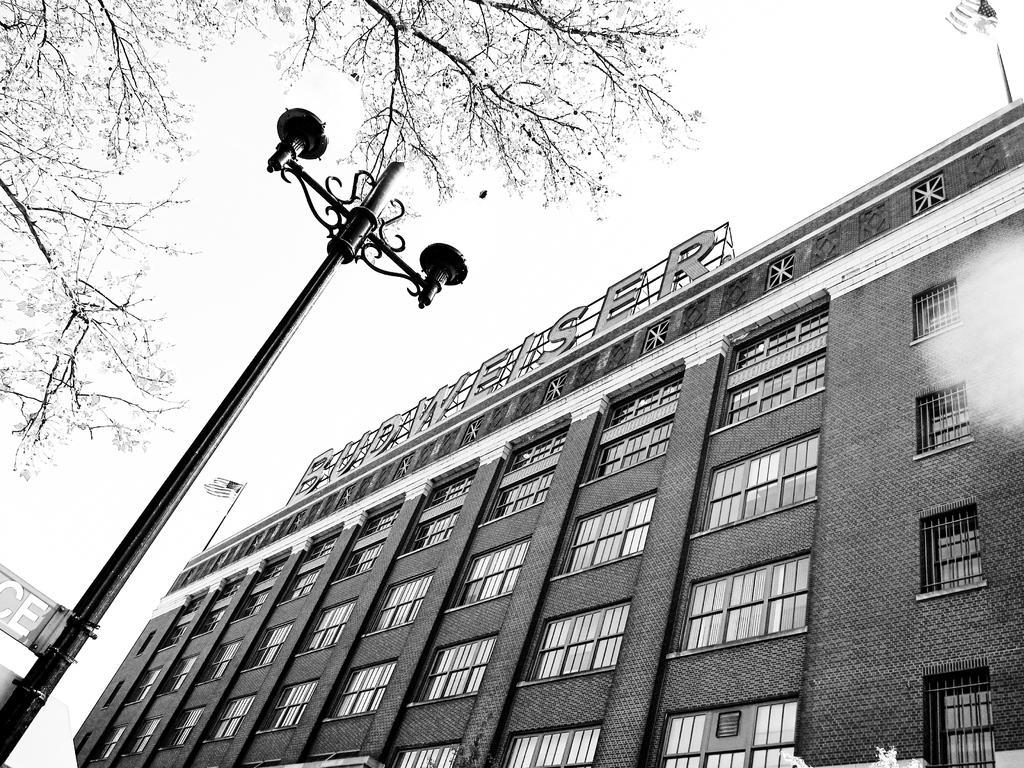Can you describe this image briefly? In this image I can see a building, number of windows, a pole, a board, branches of a tree, few lights and here I can see a flag. I can also see something is written over here and I can see this image is black and white in colour. 